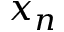<formula> <loc_0><loc_0><loc_500><loc_500>x _ { n }</formula> 